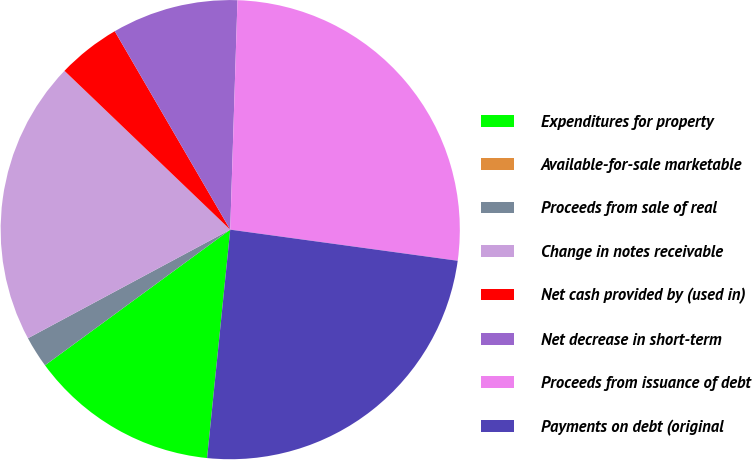Convert chart to OTSL. <chart><loc_0><loc_0><loc_500><loc_500><pie_chart><fcel>Expenditures for property<fcel>Available-for-sale marketable<fcel>Proceeds from sale of real<fcel>Change in notes receivable<fcel>Net cash provided by (used in)<fcel>Net decrease in short-term<fcel>Proceeds from issuance of debt<fcel>Payments on debt (original<nl><fcel>13.33%<fcel>0.0%<fcel>2.22%<fcel>20.0%<fcel>4.45%<fcel>8.89%<fcel>26.66%<fcel>24.44%<nl></chart> 